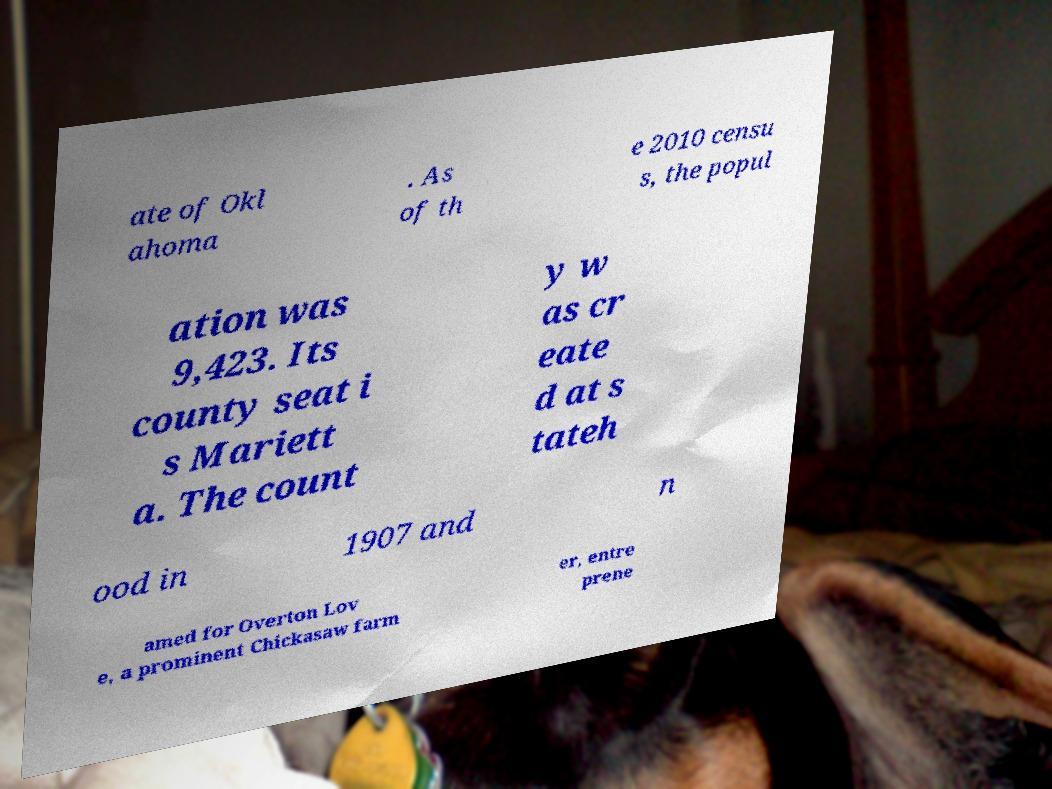Can you accurately transcribe the text from the provided image for me? ate of Okl ahoma . As of th e 2010 censu s, the popul ation was 9,423. Its county seat i s Mariett a. The count y w as cr eate d at s tateh ood in 1907 and n amed for Overton Lov e, a prominent Chickasaw farm er, entre prene 